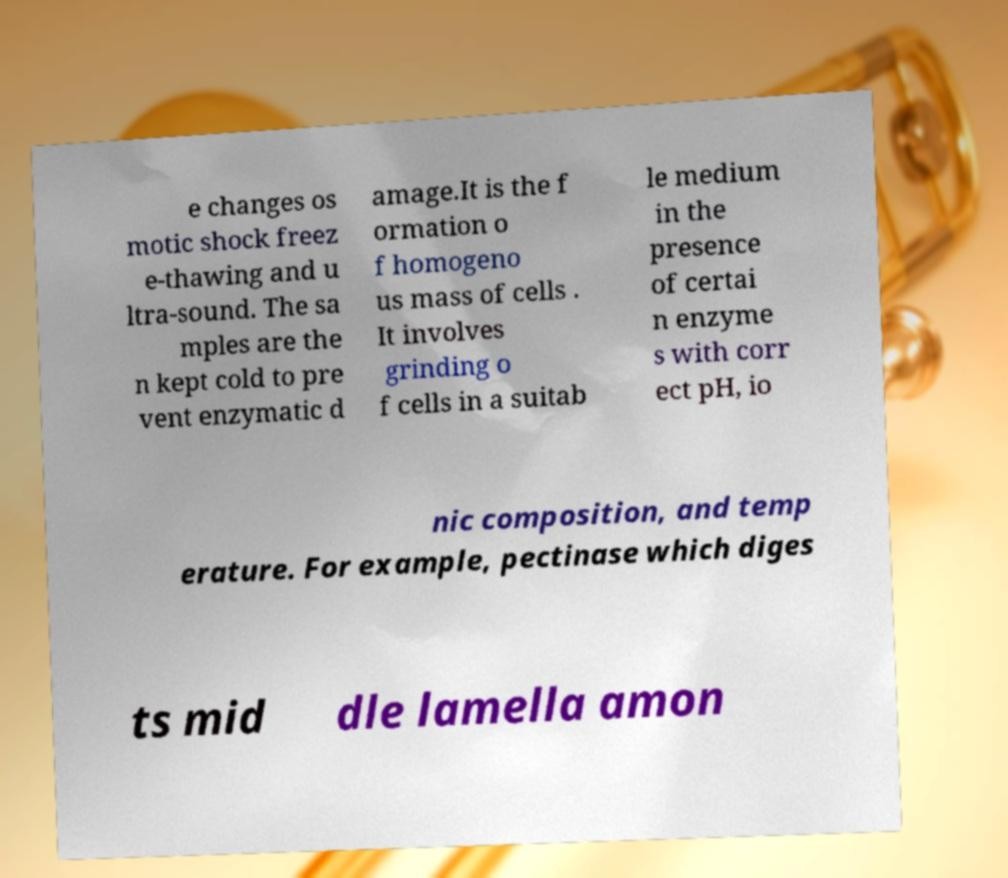Can you read and provide the text displayed in the image?This photo seems to have some interesting text. Can you extract and type it out for me? e changes os motic shock freez e-thawing and u ltra-sound. The sa mples are the n kept cold to pre vent enzymatic d amage.It is the f ormation o f homogeno us mass of cells . It involves grinding o f cells in a suitab le medium in the presence of certai n enzyme s with corr ect pH, io nic composition, and temp erature. For example, pectinase which diges ts mid dle lamella amon 